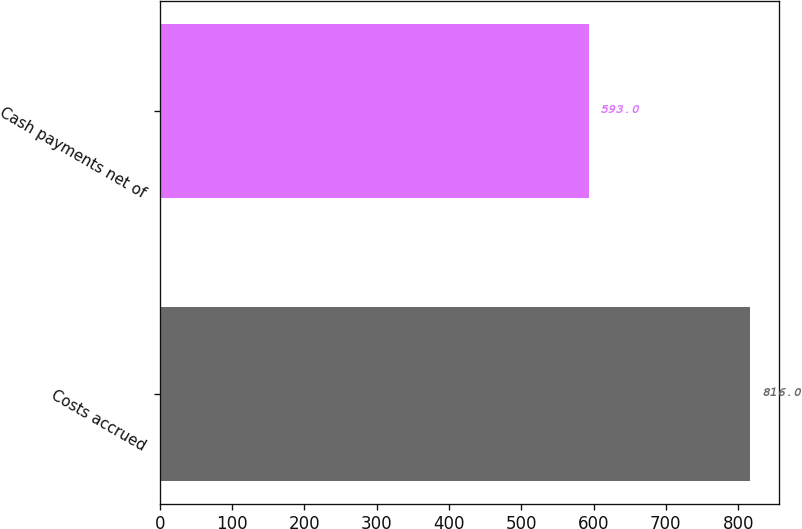<chart> <loc_0><loc_0><loc_500><loc_500><bar_chart><fcel>Costs accrued<fcel>Cash payments net of<nl><fcel>816<fcel>593<nl></chart> 